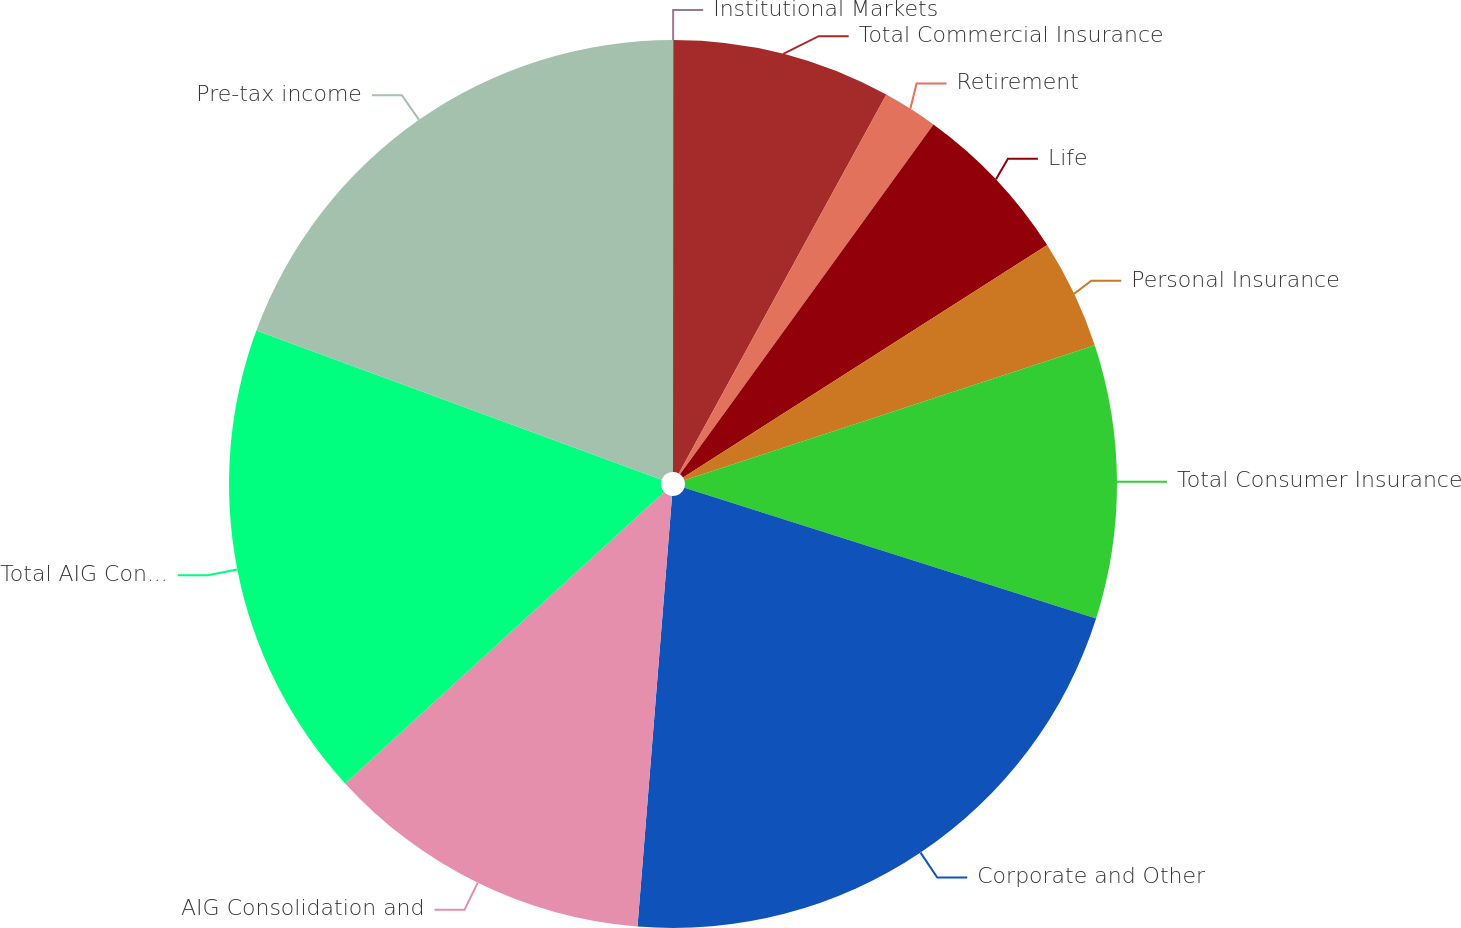<chart> <loc_0><loc_0><loc_500><loc_500><pie_chart><fcel>Institutional Markets<fcel>Total Commercial Insurance<fcel>Retirement<fcel>Life<fcel>Personal Insurance<fcel>Total Consumer Insurance<fcel>Corporate and Other<fcel>AIG Consolidation and<fcel>Total AIG Consolidated pre-tax<fcel>Pre-tax income<nl><fcel>0.01%<fcel>7.97%<fcel>2.0%<fcel>5.98%<fcel>3.99%<fcel>9.96%<fcel>21.38%<fcel>11.95%<fcel>17.4%<fcel>19.39%<nl></chart> 